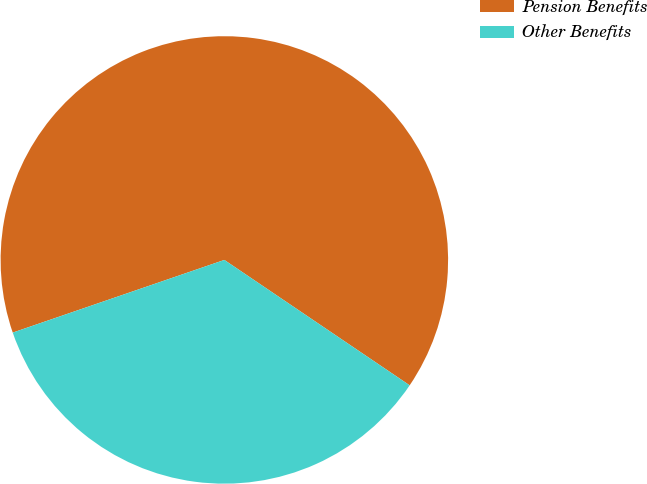<chart> <loc_0><loc_0><loc_500><loc_500><pie_chart><fcel>Pension Benefits<fcel>Other Benefits<nl><fcel>64.73%<fcel>35.27%<nl></chart> 